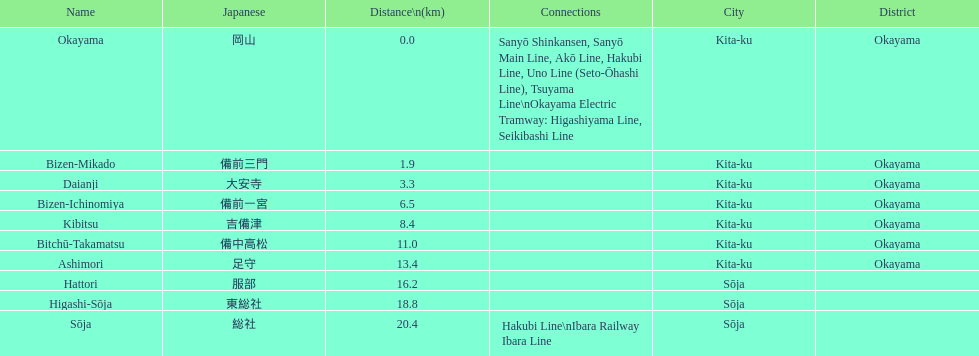Name only the stations that have connections to other lines. Okayama, Sōja. 